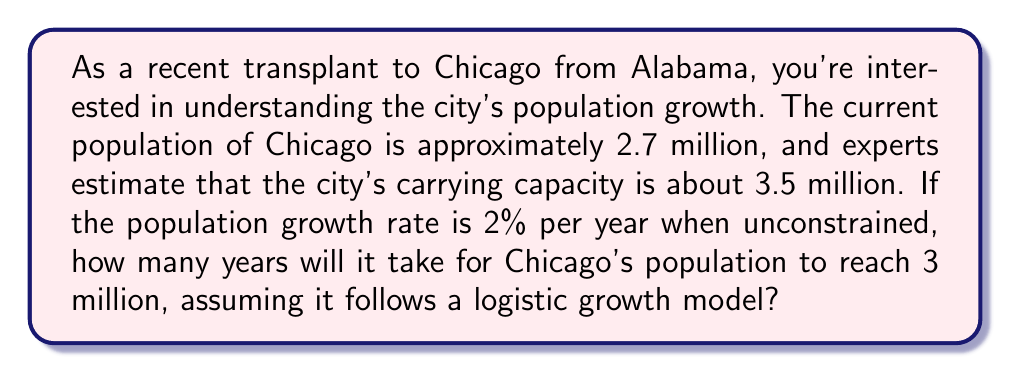Solve this math problem. Let's approach this step-by-step using the logistic growth model:

1) The logistic growth model is given by the differential equation:

   $$\frac{dP}{dt} = rP(1-\frac{P}{K})$$

   where $P$ is the population, $t$ is time, $r$ is the growth rate, and $K$ is the carrying capacity.

2) Given information:
   - Current population, $P_0 = 2.7$ million
   - Carrying capacity, $K = 3.5$ million
   - Growth rate, $r = 0.02$ (2% per year)
   - Target population, $P = 3$ million

3) The solution to the logistic equation is:

   $$P(t) = \frac{KP_0}{P_0 + (K-P_0)e^{-rt}}$$

4) Substituting the known values:

   $$3 = \frac{3.5 \cdot 2.7}{2.7 + (3.5-2.7)e^{-0.02t}}$$

5) Simplifying:

   $$3 = \frac{9.45}{2.7 + 0.8e^{-0.02t}}$$

6) Multiplying both sides by the denominator:

   $$9 + 2.4e^{-0.02t} = 9.45$$

7) Subtracting 9 from both sides:

   $$2.4e^{-0.02t} = 0.45$$

8) Dividing both sides by 2.4:

   $$e^{-0.02t} = 0.1875$$

9) Taking the natural log of both sides:

   $$-0.02t = \ln(0.1875)$$

10) Solving for $t$:

    $$t = -\frac{\ln(0.1875)}{0.02} \approx 84.73$$

Therefore, it will take approximately 85 years for Chicago's population to reach 3 million.
Answer: 85 years 